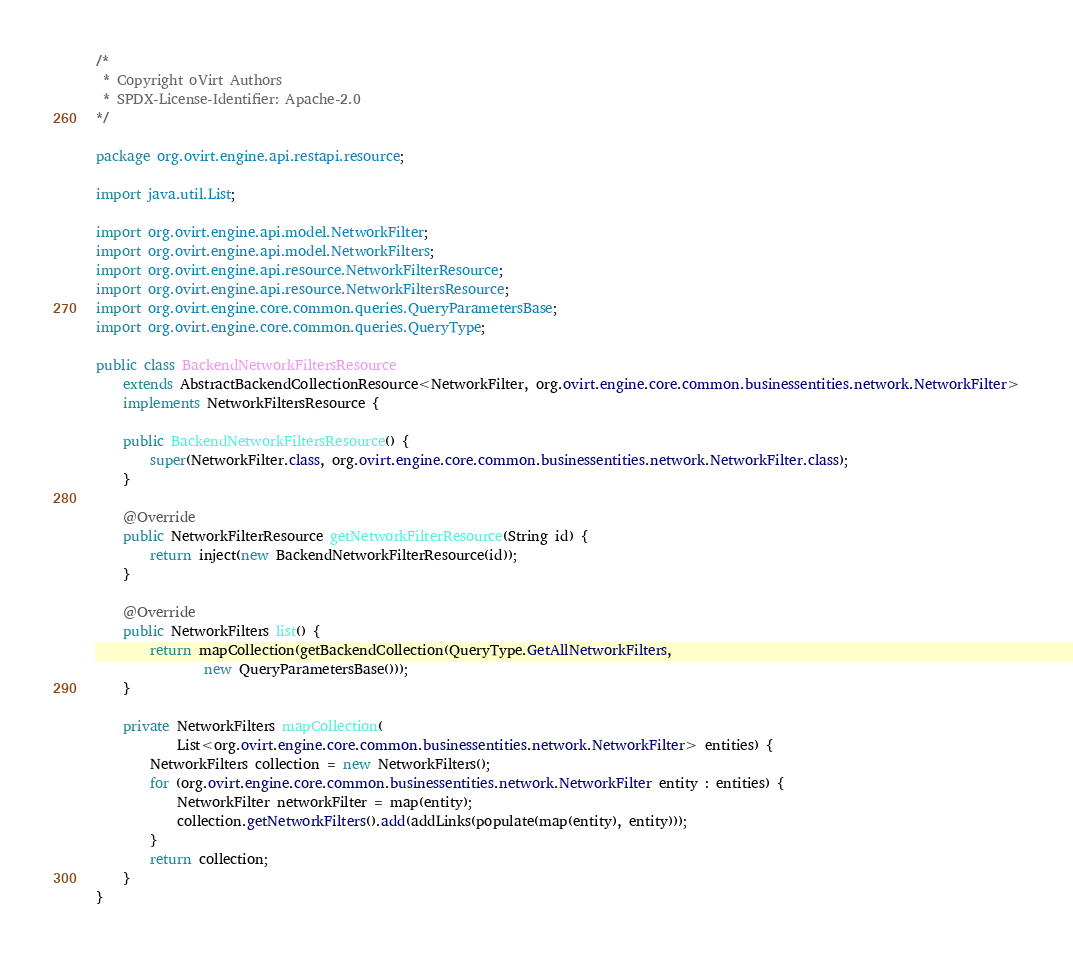<code> <loc_0><loc_0><loc_500><loc_500><_Java_>/*
 * Copyright oVirt Authors
 * SPDX-License-Identifier: Apache-2.0
*/

package org.ovirt.engine.api.restapi.resource;

import java.util.List;

import org.ovirt.engine.api.model.NetworkFilter;
import org.ovirt.engine.api.model.NetworkFilters;
import org.ovirt.engine.api.resource.NetworkFilterResource;
import org.ovirt.engine.api.resource.NetworkFiltersResource;
import org.ovirt.engine.core.common.queries.QueryParametersBase;
import org.ovirt.engine.core.common.queries.QueryType;

public class BackendNetworkFiltersResource
    extends AbstractBackendCollectionResource<NetworkFilter, org.ovirt.engine.core.common.businessentities.network.NetworkFilter>
    implements NetworkFiltersResource {

    public BackendNetworkFiltersResource() {
        super(NetworkFilter.class, org.ovirt.engine.core.common.businessentities.network.NetworkFilter.class);
    }

    @Override
    public NetworkFilterResource getNetworkFilterResource(String id) {
        return inject(new BackendNetworkFilterResource(id));
    }

    @Override
    public NetworkFilters list() {
        return mapCollection(getBackendCollection(QueryType.GetAllNetworkFilters,
                new QueryParametersBase()));
    }

    private NetworkFilters mapCollection(
            List<org.ovirt.engine.core.common.businessentities.network.NetworkFilter> entities) {
        NetworkFilters collection = new NetworkFilters();
        for (org.ovirt.engine.core.common.businessentities.network.NetworkFilter entity : entities) {
            NetworkFilter networkFilter = map(entity);
            collection.getNetworkFilters().add(addLinks(populate(map(entity), entity)));
        }
        return collection;
    }
}
</code> 